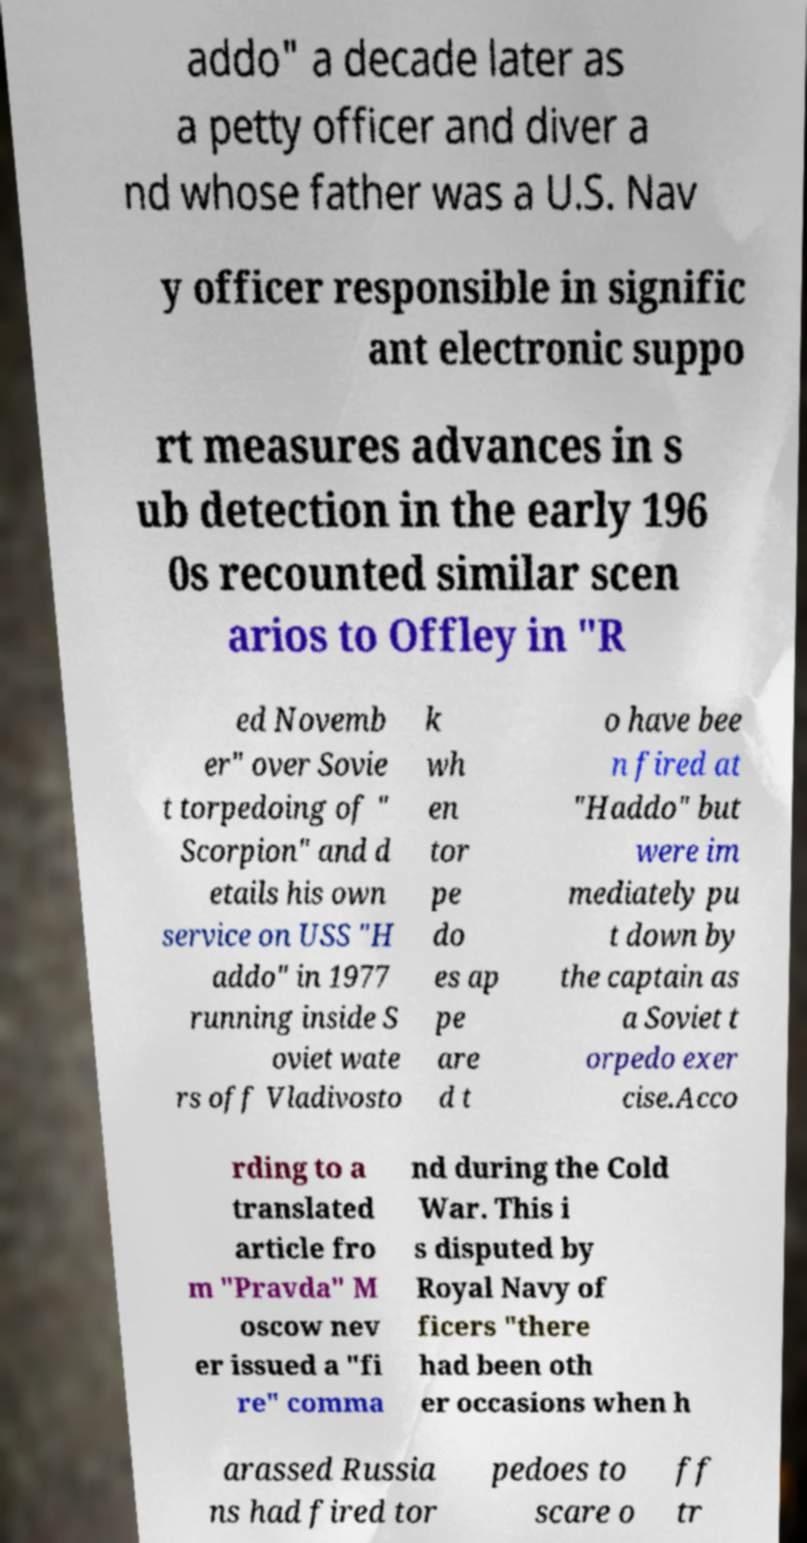There's text embedded in this image that I need extracted. Can you transcribe it verbatim? addo" a decade later as a petty officer and diver a nd whose father was a U.S. Nav y officer responsible in signific ant electronic suppo rt measures advances in s ub detection in the early 196 0s recounted similar scen arios to Offley in "R ed Novemb er" over Sovie t torpedoing of " Scorpion" and d etails his own service on USS "H addo" in 1977 running inside S oviet wate rs off Vladivosto k wh en tor pe do es ap pe are d t o have bee n fired at "Haddo" but were im mediately pu t down by the captain as a Soviet t orpedo exer cise.Acco rding to a translated article fro m "Pravda" M oscow nev er issued a "fi re" comma nd during the Cold War. This i s disputed by Royal Navy of ficers "there had been oth er occasions when h arassed Russia ns had fired tor pedoes to scare o ff tr 